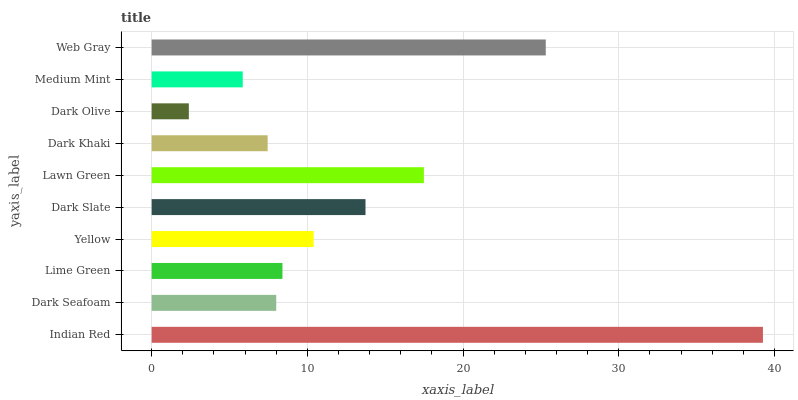Is Dark Olive the minimum?
Answer yes or no. Yes. Is Indian Red the maximum?
Answer yes or no. Yes. Is Dark Seafoam the minimum?
Answer yes or no. No. Is Dark Seafoam the maximum?
Answer yes or no. No. Is Indian Red greater than Dark Seafoam?
Answer yes or no. Yes. Is Dark Seafoam less than Indian Red?
Answer yes or no. Yes. Is Dark Seafoam greater than Indian Red?
Answer yes or no. No. Is Indian Red less than Dark Seafoam?
Answer yes or no. No. Is Yellow the high median?
Answer yes or no. Yes. Is Lime Green the low median?
Answer yes or no. Yes. Is Dark Khaki the high median?
Answer yes or no. No. Is Dark Khaki the low median?
Answer yes or no. No. 